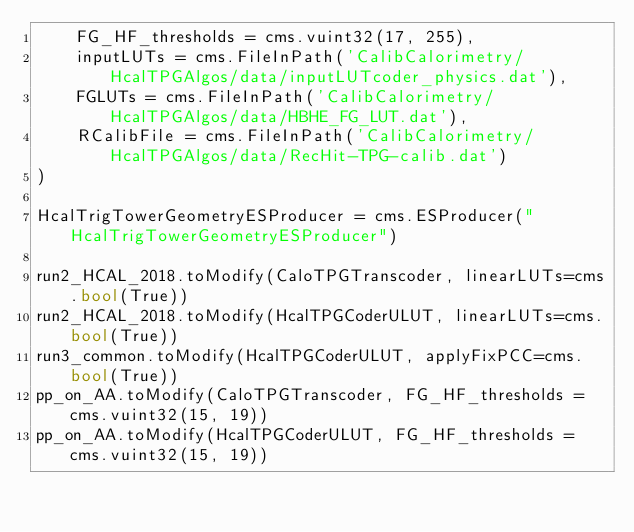<code> <loc_0><loc_0><loc_500><loc_500><_Python_>    FG_HF_thresholds = cms.vuint32(17, 255),
    inputLUTs = cms.FileInPath('CalibCalorimetry/HcalTPGAlgos/data/inputLUTcoder_physics.dat'),
    FGLUTs = cms.FileInPath('CalibCalorimetry/HcalTPGAlgos/data/HBHE_FG_LUT.dat'),
    RCalibFile = cms.FileInPath('CalibCalorimetry/HcalTPGAlgos/data/RecHit-TPG-calib.dat')
)

HcalTrigTowerGeometryESProducer = cms.ESProducer("HcalTrigTowerGeometryESProducer")

run2_HCAL_2018.toModify(CaloTPGTranscoder, linearLUTs=cms.bool(True))
run2_HCAL_2018.toModify(HcalTPGCoderULUT, linearLUTs=cms.bool(True))
run3_common.toModify(HcalTPGCoderULUT, applyFixPCC=cms.bool(True))
pp_on_AA.toModify(CaloTPGTranscoder, FG_HF_thresholds = cms.vuint32(15, 19))
pp_on_AA.toModify(HcalTPGCoderULUT, FG_HF_thresholds = cms.vuint32(15, 19))
</code> 